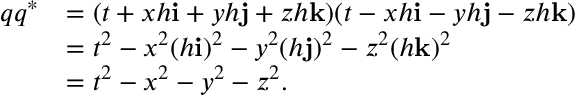Convert formula to latex. <formula><loc_0><loc_0><loc_500><loc_500>{ \begin{array} { r l } { q q ^ { * } } & { = ( t + x h i + y h j + z h k ) ( t - x h i - y h j - z h k ) } \\ & { = t ^ { 2 } - x ^ { 2 } ( h i ) ^ { 2 } - y ^ { 2 } ( h j ) ^ { 2 } - z ^ { 2 } ( h k ) ^ { 2 } } \\ & { = t ^ { 2 } - x ^ { 2 } - y ^ { 2 } - z ^ { 2 } . } \end{array} }</formula> 